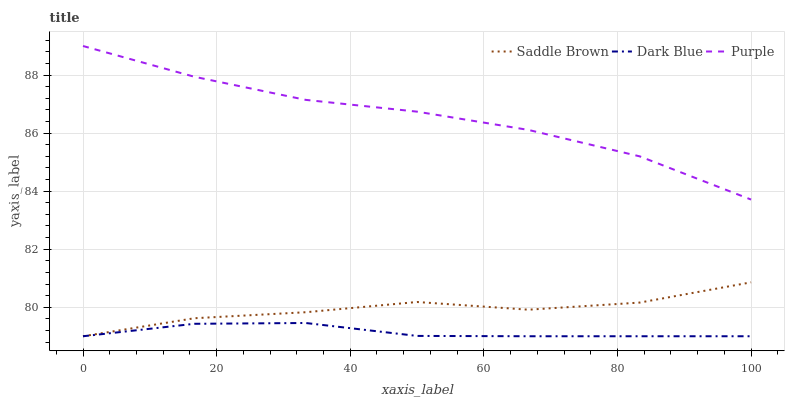Does Saddle Brown have the minimum area under the curve?
Answer yes or no. No. Does Saddle Brown have the maximum area under the curve?
Answer yes or no. No. Is Saddle Brown the smoothest?
Answer yes or no. No. Is Dark Blue the roughest?
Answer yes or no. No. Does Saddle Brown have the highest value?
Answer yes or no. No. Is Dark Blue less than Purple?
Answer yes or no. Yes. Is Purple greater than Dark Blue?
Answer yes or no. Yes. Does Dark Blue intersect Purple?
Answer yes or no. No. 